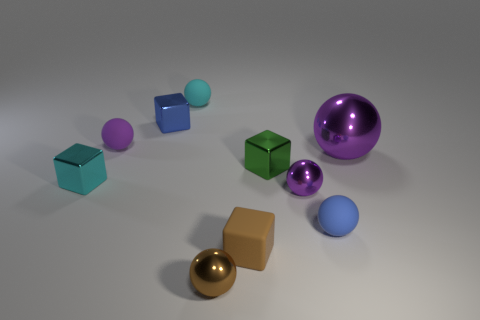How many purple spheres must be subtracted to get 2 purple spheres? 1 Subtract all brown cubes. How many purple balls are left? 3 Subtract 2 spheres. How many spheres are left? 4 Subtract all blue spheres. How many spheres are left? 5 Subtract all brown balls. How many balls are left? 5 Subtract all yellow cubes. Subtract all blue balls. How many cubes are left? 4 Subtract all blocks. How many objects are left? 6 Add 1 small purple rubber things. How many small purple rubber things exist? 2 Subtract 0 gray cylinders. How many objects are left? 10 Subtract all tiny gray balls. Subtract all big purple shiny objects. How many objects are left? 9 